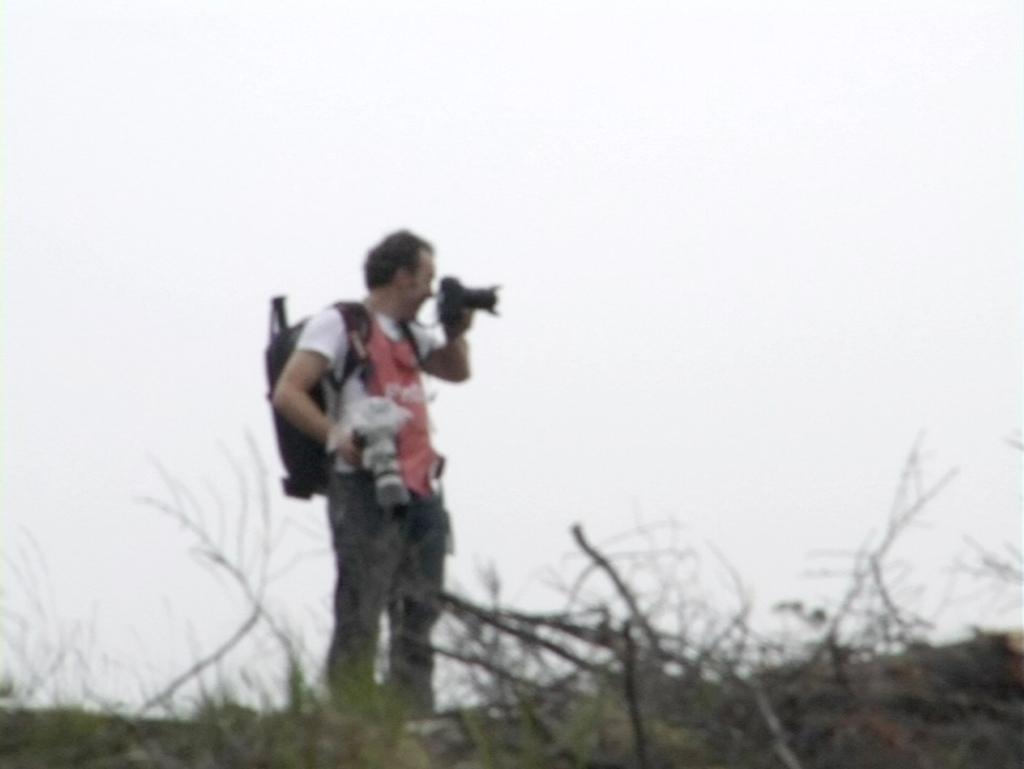In one or two sentences, can you explain what this image depicts? At the bottom of the picture, we see the trees. In the middle of the picture, we see a man in the white T-shirt is wearing the backpack. He is holding the cameras in his hands and he might be clicking photos with the camera. In the background, we see the sky and this picture is blurred. 